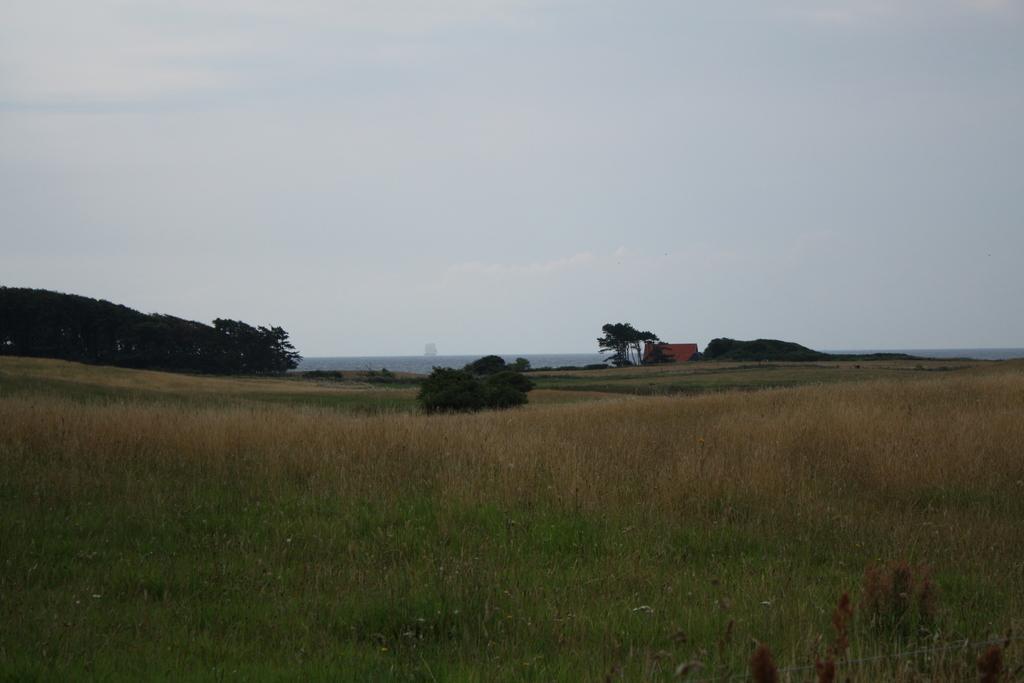In one or two sentences, can you explain what this image depicts? In the image we can see grass, trees and the cloudy sky. 